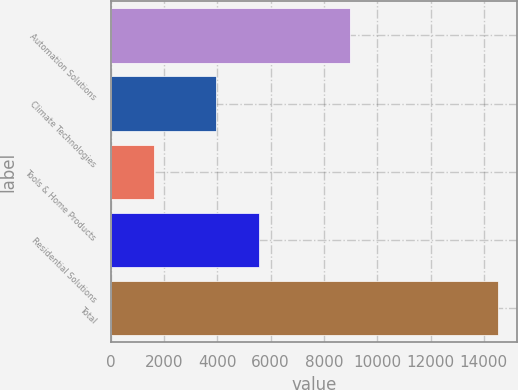<chart> <loc_0><loc_0><loc_500><loc_500><bar_chart><fcel>Automation Solutions<fcel>Climate Technologies<fcel>Tools & Home Products<fcel>Residential Solutions<fcel>Total<nl><fcel>8977<fcel>3944<fcel>1611<fcel>5555<fcel>14522<nl></chart> 